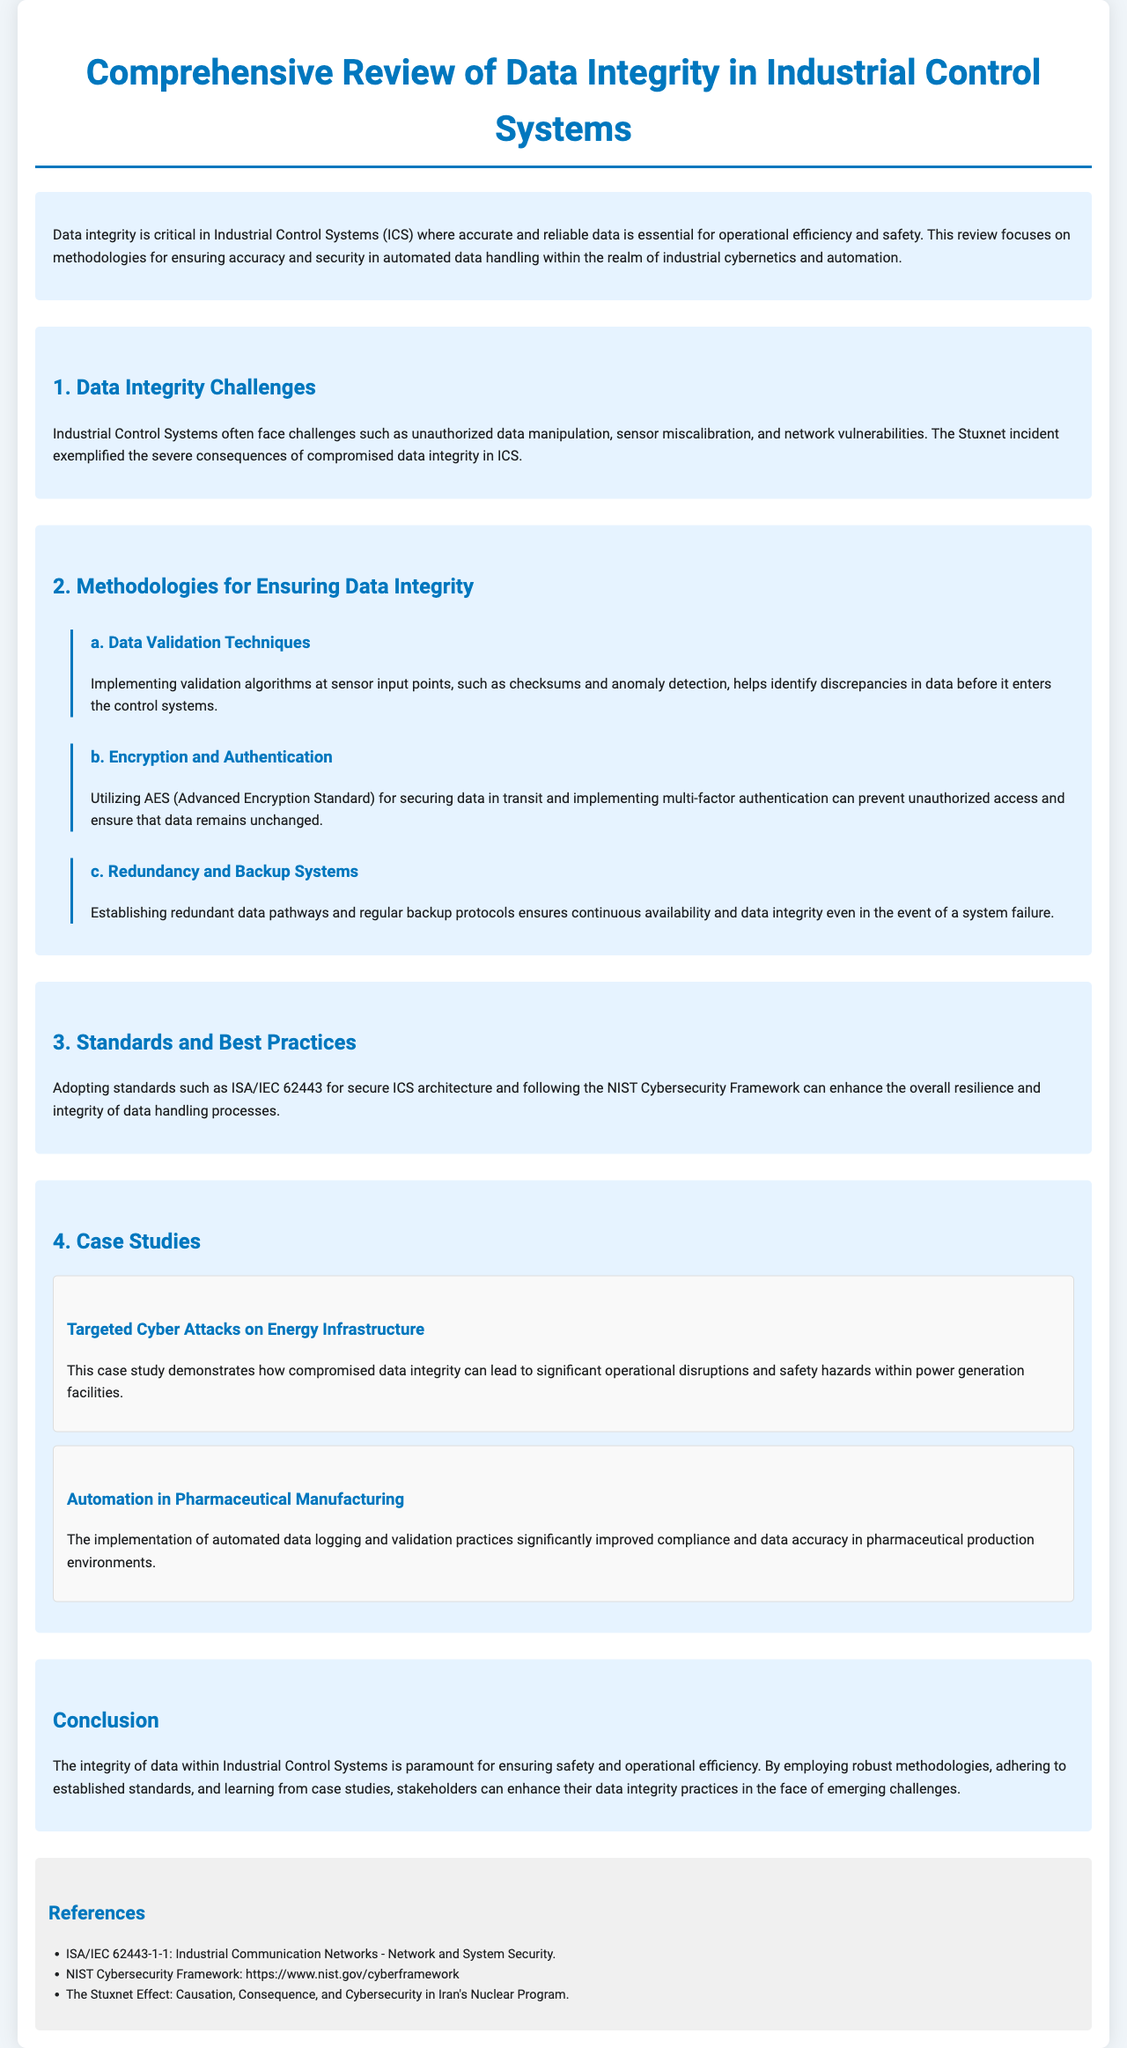What is the title of the document? The title of the document is provided at the top under the main heading.
Answer: Comprehensive Review of Data Integrity in Industrial Control Systems What incident exemplified compromised data integrity in ICS? The document references a significant incident that serves as a case study for data integrity issues.
Answer: The Stuxnet incident What encryption standard is mentioned for securing data? The document specifies a standard used for data security during transmission.
Answer: AES (Advanced Encryption Standard) How many methodologies for ensuring data integrity are listed? The section on methodologies outlines distinct strategies employed to maintain data integrity.
Answer: Three What is the focus of the case study related to energy infrastructure? This case study illustrates consequences related to a specific type of cyber attack.
Answer: Targeted Cyber Attacks on Energy Infrastructure Which framework is recommended for enhancing data handling resilience? The document suggests adopting a particular cybersecurity framework for best practices.
Answer: NIST Cybersecurity Framework What was improved in pharmaceutical manufacturing through automation? The report indicates specific outcomes resulting from enhanced processes in this industry.
Answer: Compliance and data accuracy What is mentioned as a challenge for Industrial Control Systems? The document lists potential issues that affect the operation and reliability of systems.
Answer: Unauthorized data manipulation 